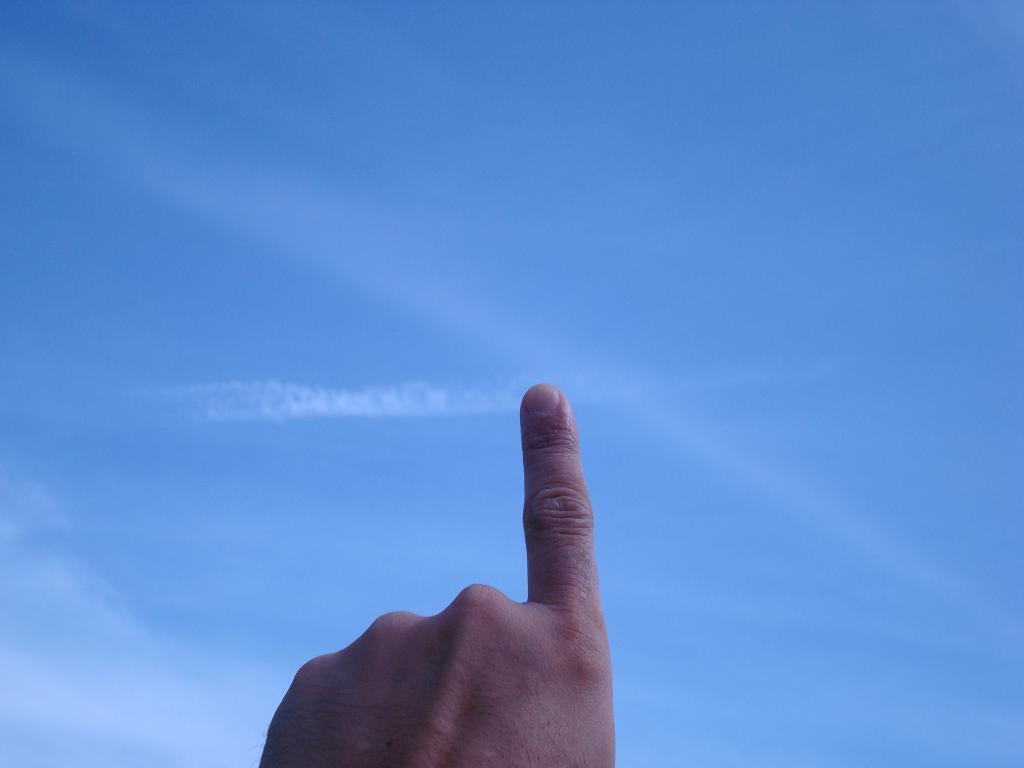How would you summarize this image in a sentence or two? In this image we can see there is a person's hand pointing towards the sky. 